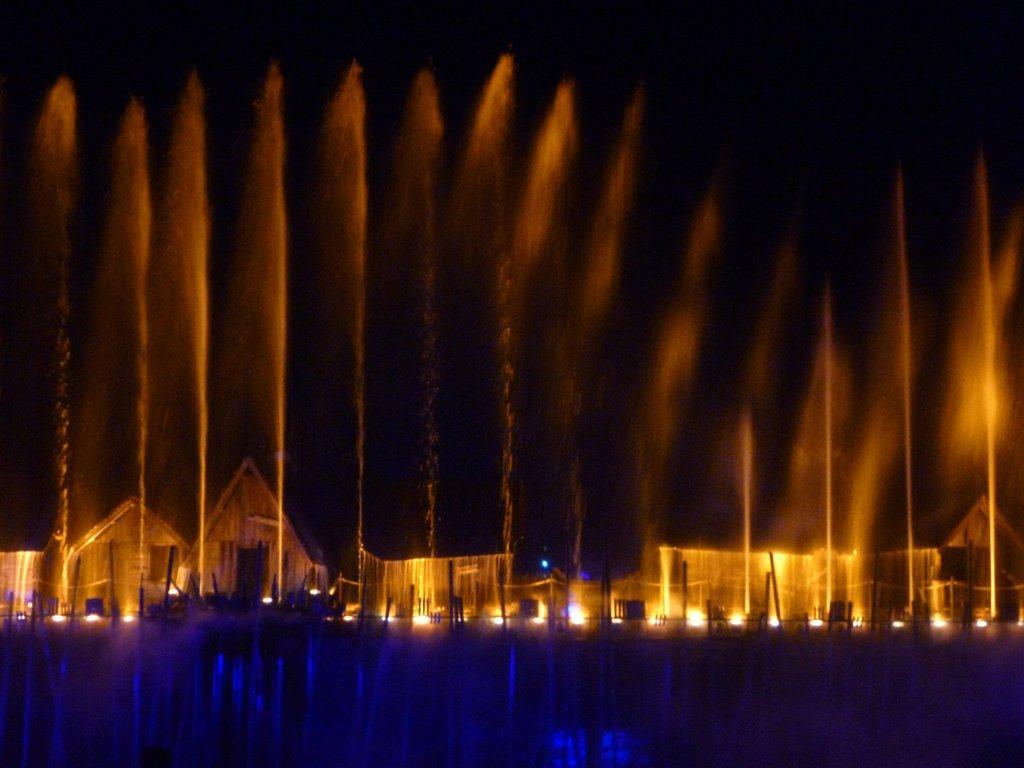How would you summarize this image in a sentence or two? In this image there are few water fountains. Behind there are few houses. Few lights are on the land. 